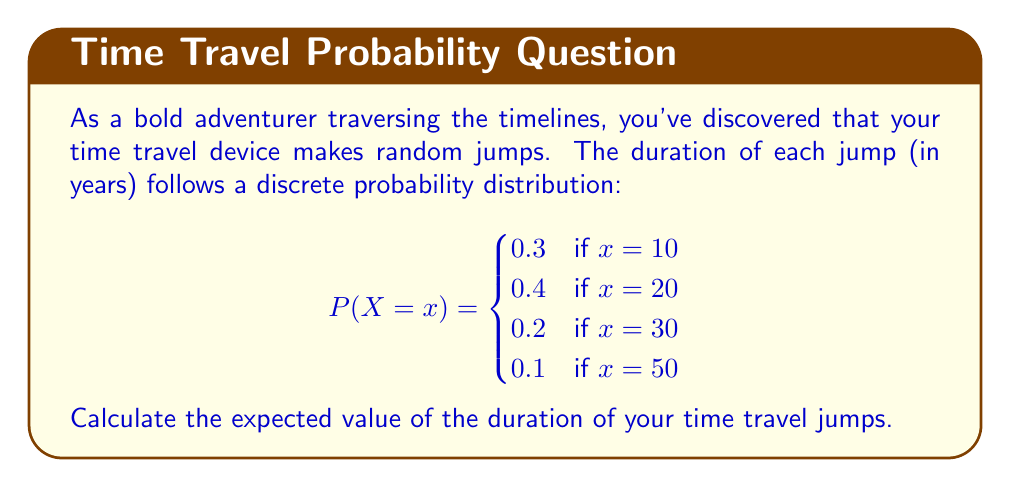What is the answer to this math problem? To calculate the expected value of a discrete random variable, we use the formula:

$$E(X) = \sum_{x} x \cdot P(X = x)$$

Let's calculate this step by step:

1) First, we multiply each possible value of X by its probability:

   For x = 10: $10 \cdot 0.3 = 3$
   For x = 20: $20 \cdot 0.4 = 8$
   For x = 30: $30 \cdot 0.2 = 6$
   For x = 50: $50 \cdot 0.1 = 5$

2) Now, we sum these products:

   $$E(X) = 3 + 8 + 6 + 5 = 22$$

Therefore, the expected value of the duration of your time travel jumps is 22 years.
Answer: $E(X) = 22$ years 